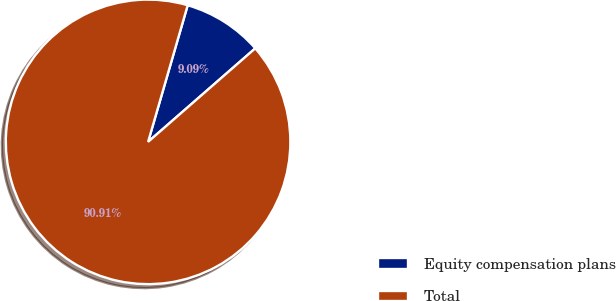<chart> <loc_0><loc_0><loc_500><loc_500><pie_chart><fcel>Equity compensation plans<fcel>Total<nl><fcel>9.09%<fcel>90.91%<nl></chart> 